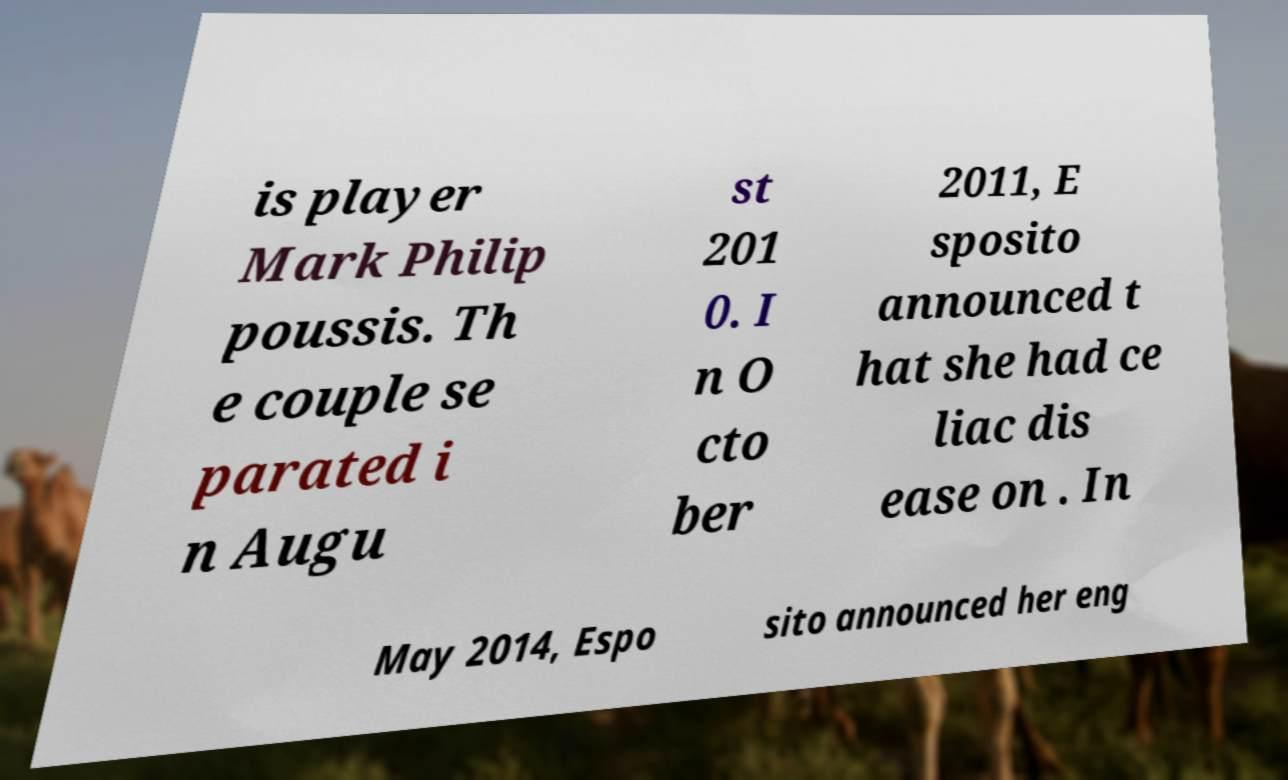I need the written content from this picture converted into text. Can you do that? is player Mark Philip poussis. Th e couple se parated i n Augu st 201 0. I n O cto ber 2011, E sposito announced t hat she had ce liac dis ease on . In May 2014, Espo sito announced her eng 